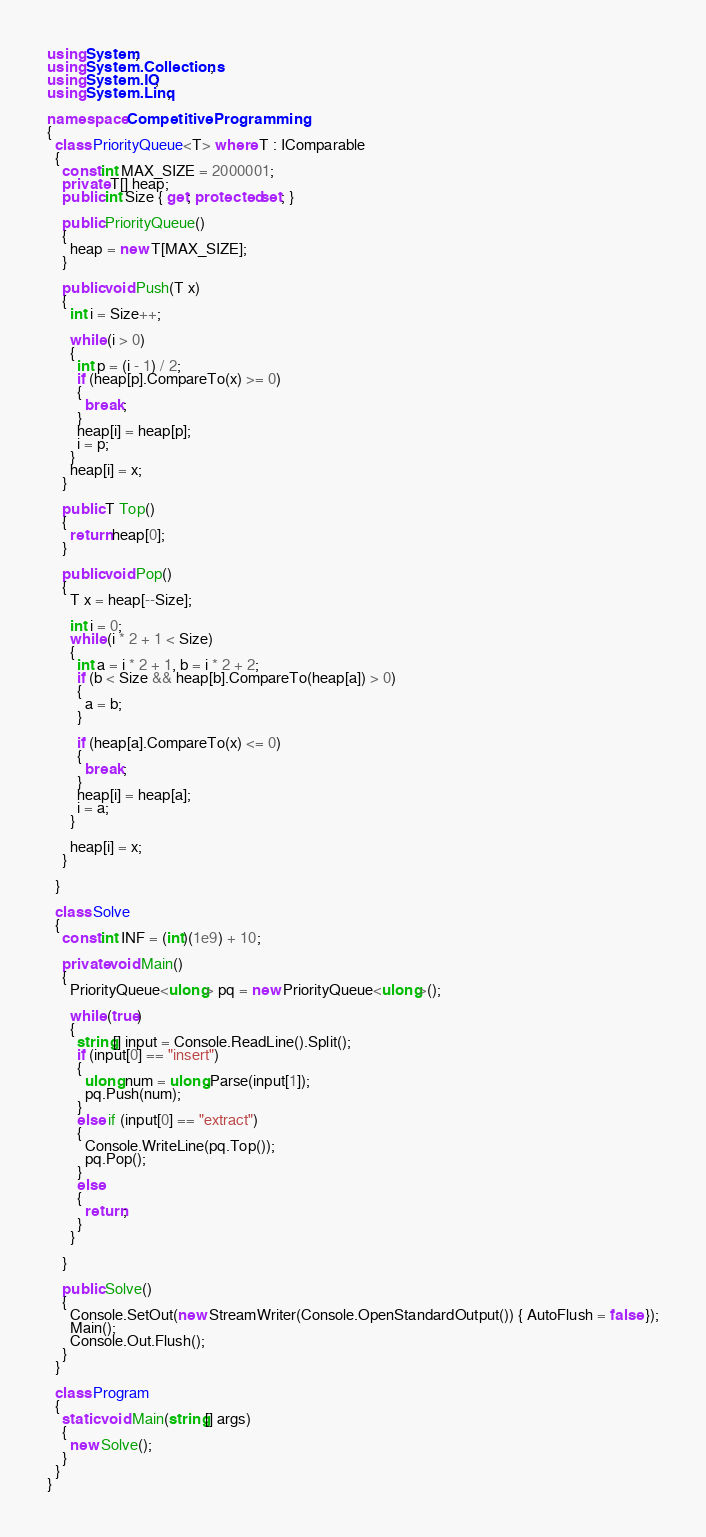<code> <loc_0><loc_0><loc_500><loc_500><_C#_>using System;
using System.Collections;
using System.IO;
using System.Linq;

namespace CompetitiveProgramming
{
  class PriorityQueue<T> where T : IComparable
  {
    const int MAX_SIZE = 2000001;
    private T[] heap;
    public int Size { get; protected set; }

    public PriorityQueue()
    {
      heap = new T[MAX_SIZE];
    }

    public void Push(T x)
    {
      int i = Size++;
      
      while (i > 0)
      {
        int p = (i - 1) / 2;
        if (heap[p].CompareTo(x) >= 0)
        {
          break;
        }
        heap[i] = heap[p];
        i = p;
      }
      heap[i] = x;
    }

    public T Top()
    {
      return heap[0];
    }

    public void Pop()
    {
      T x = heap[--Size];

      int i = 0;
      while (i * 2 + 1 < Size)
      {
        int a = i * 2 + 1, b = i * 2 + 2;
        if (b < Size && heap[b].CompareTo(heap[a]) > 0)
        {
          a = b;
        }

        if (heap[a].CompareTo(x) <= 0)
        {
          break;
        }
        heap[i] = heap[a];
        i = a;
      }

      heap[i] = x;
    }

  }

  class Solve
  {
    const int INF = (int)(1e9) + 10;

    private void Main()
    {
      PriorityQueue<ulong> pq = new PriorityQueue<ulong>();

      while (true)
      {
        string[] input = Console.ReadLine().Split();
        if (input[0] == "insert")
        {
          ulong num = ulong.Parse(input[1]);
          pq.Push(num);
        }
        else if (input[0] == "extract")
        {
          Console.WriteLine(pq.Top());
          pq.Pop();
        }
        else
        {
          return;
        }
      }
      
    }

    public Solve()
    {
      Console.SetOut(new StreamWriter(Console.OpenStandardOutput()) { AutoFlush = false });
      Main();
      Console.Out.Flush();
    }
  }

  class Program
  {
    static void Main(string[] args)
    {
      new Solve();
    }
  }
}</code> 